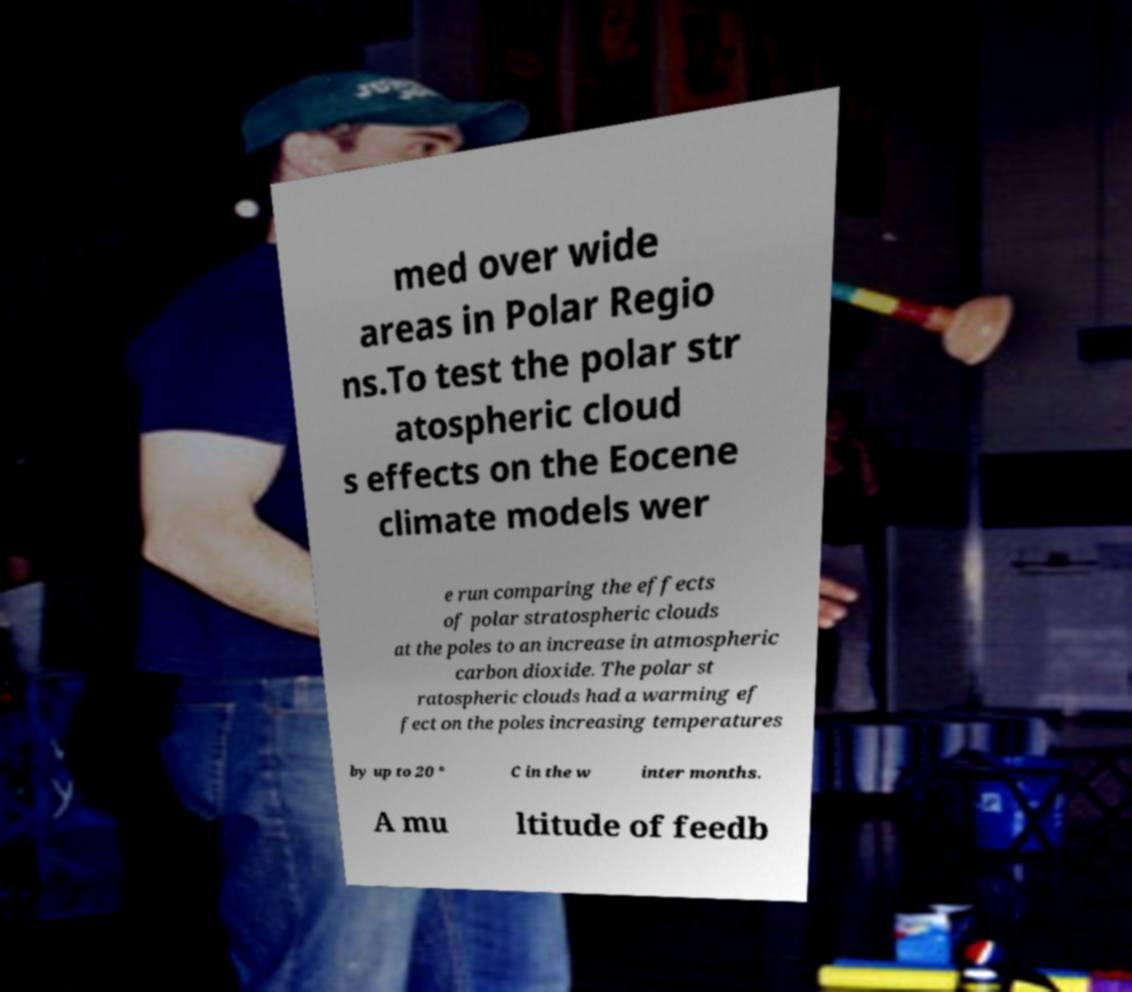What messages or text are displayed in this image? I need them in a readable, typed format. med over wide areas in Polar Regio ns.To test the polar str atospheric cloud s effects on the Eocene climate models wer e run comparing the effects of polar stratospheric clouds at the poles to an increase in atmospheric carbon dioxide. The polar st ratospheric clouds had a warming ef fect on the poles increasing temperatures by up to 20 ° C in the w inter months. A mu ltitude of feedb 